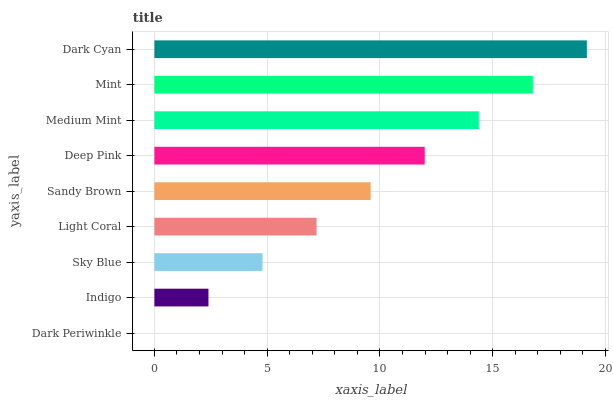Is Dark Periwinkle the minimum?
Answer yes or no. Yes. Is Dark Cyan the maximum?
Answer yes or no. Yes. Is Indigo the minimum?
Answer yes or no. No. Is Indigo the maximum?
Answer yes or no. No. Is Indigo greater than Dark Periwinkle?
Answer yes or no. Yes. Is Dark Periwinkle less than Indigo?
Answer yes or no. Yes. Is Dark Periwinkle greater than Indigo?
Answer yes or no. No. Is Indigo less than Dark Periwinkle?
Answer yes or no. No. Is Sandy Brown the high median?
Answer yes or no. Yes. Is Sandy Brown the low median?
Answer yes or no. Yes. Is Indigo the high median?
Answer yes or no. No. Is Mint the low median?
Answer yes or no. No. 